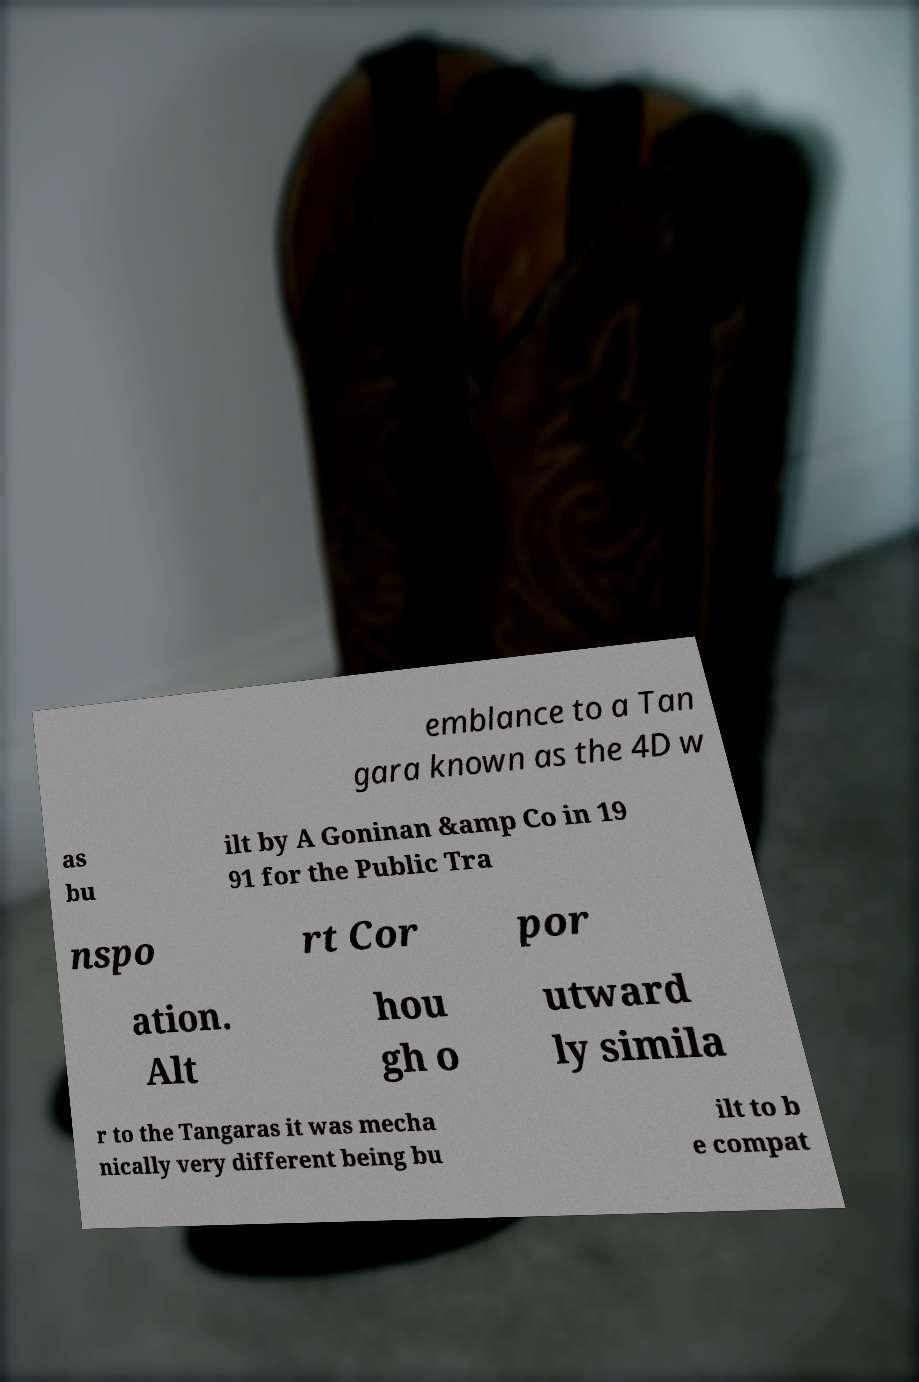Can you read and provide the text displayed in the image?This photo seems to have some interesting text. Can you extract and type it out for me? emblance to a Tan gara known as the 4D w as bu ilt by A Goninan &amp Co in 19 91 for the Public Tra nspo rt Cor por ation. Alt hou gh o utward ly simila r to the Tangaras it was mecha nically very different being bu ilt to b e compat 